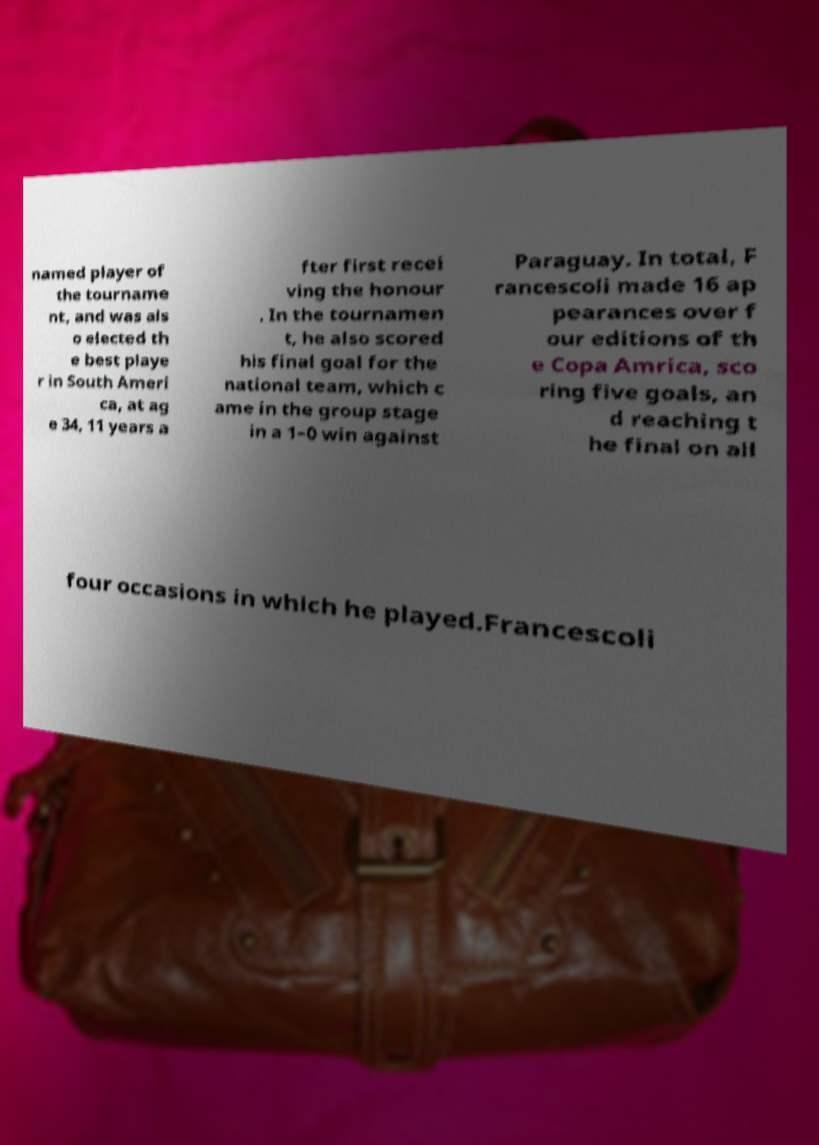For documentation purposes, I need the text within this image transcribed. Could you provide that? named player of the tourname nt, and was als o elected th e best playe r in South Ameri ca, at ag e 34, 11 years a fter first recei ving the honour . In the tournamen t, he also scored his final goal for the national team, which c ame in the group stage in a 1–0 win against Paraguay. In total, F rancescoli made 16 ap pearances over f our editions of th e Copa Amrica, sco ring five goals, an d reaching t he final on all four occasions in which he played.Francescoli 